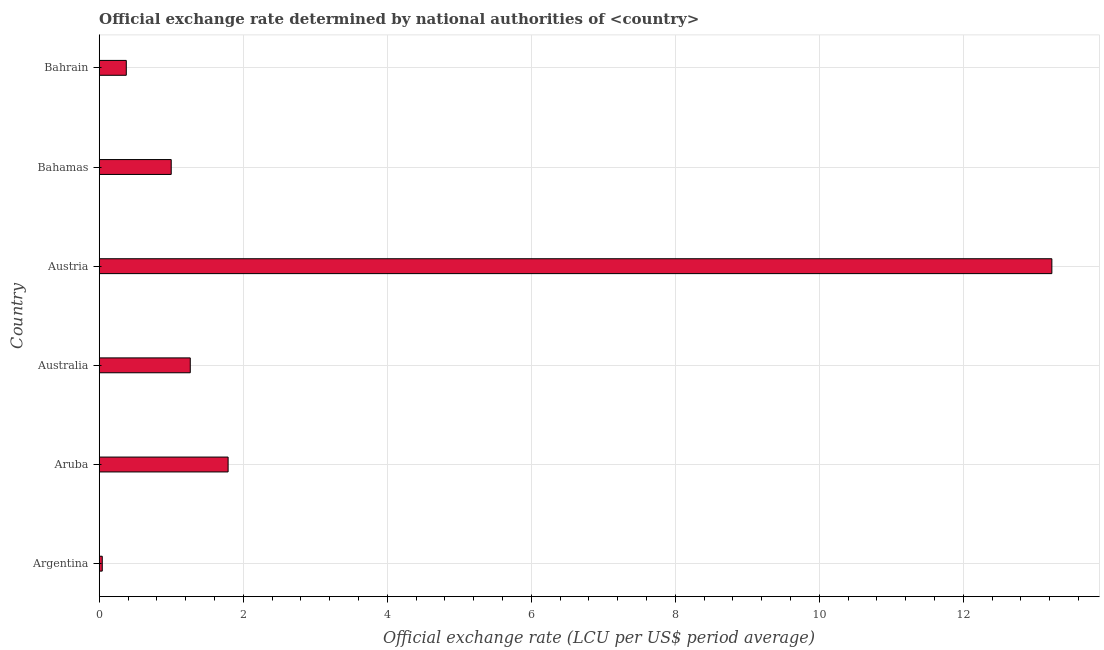What is the title of the graph?
Give a very brief answer. Official exchange rate determined by national authorities of <country>. What is the label or title of the X-axis?
Provide a succinct answer. Official exchange rate (LCU per US$ period average). What is the label or title of the Y-axis?
Make the answer very short. Country. What is the official exchange rate in Aruba?
Give a very brief answer. 1.79. Across all countries, what is the maximum official exchange rate?
Your response must be concise. 13.23. Across all countries, what is the minimum official exchange rate?
Ensure brevity in your answer.  0.04. What is the sum of the official exchange rate?
Your answer should be compact. 17.7. What is the difference between the official exchange rate in Bahamas and Bahrain?
Your response must be concise. 0.62. What is the average official exchange rate per country?
Your answer should be compact. 2.95. What is the median official exchange rate?
Your answer should be compact. 1.13. What is the ratio of the official exchange rate in Argentina to that in Bahamas?
Provide a succinct answer. 0.04. What is the difference between the highest and the second highest official exchange rate?
Provide a succinct answer. 11.44. Is the sum of the official exchange rate in Argentina and Aruba greater than the maximum official exchange rate across all countries?
Your response must be concise. No. What is the difference between the highest and the lowest official exchange rate?
Ensure brevity in your answer.  13.19. In how many countries, is the official exchange rate greater than the average official exchange rate taken over all countries?
Provide a succinct answer. 1. How many bars are there?
Your answer should be very brief. 6. Are all the bars in the graph horizontal?
Provide a short and direct response. Yes. How many countries are there in the graph?
Make the answer very short. 6. Are the values on the major ticks of X-axis written in scientific E-notation?
Make the answer very short. No. What is the Official exchange rate (LCU per US$ period average) of Argentina?
Your answer should be very brief. 0.04. What is the Official exchange rate (LCU per US$ period average) of Aruba?
Ensure brevity in your answer.  1.79. What is the Official exchange rate (LCU per US$ period average) of Australia?
Keep it short and to the point. 1.26. What is the Official exchange rate (LCU per US$ period average) in Austria?
Your answer should be compact. 13.23. What is the Official exchange rate (LCU per US$ period average) in Bahrain?
Make the answer very short. 0.38. What is the difference between the Official exchange rate (LCU per US$ period average) in Argentina and Aruba?
Make the answer very short. -1.75. What is the difference between the Official exchange rate (LCU per US$ period average) in Argentina and Australia?
Your answer should be compact. -1.22. What is the difference between the Official exchange rate (LCU per US$ period average) in Argentina and Austria?
Give a very brief answer. -13.19. What is the difference between the Official exchange rate (LCU per US$ period average) in Argentina and Bahamas?
Offer a very short reply. -0.96. What is the difference between the Official exchange rate (LCU per US$ period average) in Argentina and Bahrain?
Your answer should be very brief. -0.33. What is the difference between the Official exchange rate (LCU per US$ period average) in Aruba and Australia?
Provide a succinct answer. 0.53. What is the difference between the Official exchange rate (LCU per US$ period average) in Aruba and Austria?
Your answer should be compact. -11.44. What is the difference between the Official exchange rate (LCU per US$ period average) in Aruba and Bahamas?
Ensure brevity in your answer.  0.79. What is the difference between the Official exchange rate (LCU per US$ period average) in Aruba and Bahrain?
Ensure brevity in your answer.  1.41. What is the difference between the Official exchange rate (LCU per US$ period average) in Australia and Austria?
Your answer should be very brief. -11.97. What is the difference between the Official exchange rate (LCU per US$ period average) in Australia and Bahamas?
Your response must be concise. 0.26. What is the difference between the Official exchange rate (LCU per US$ period average) in Australia and Bahrain?
Offer a terse response. 0.89. What is the difference between the Official exchange rate (LCU per US$ period average) in Austria and Bahamas?
Offer a terse response. 12.23. What is the difference between the Official exchange rate (LCU per US$ period average) in Austria and Bahrain?
Offer a very short reply. 12.85. What is the difference between the Official exchange rate (LCU per US$ period average) in Bahamas and Bahrain?
Offer a very short reply. 0.62. What is the ratio of the Official exchange rate (LCU per US$ period average) in Argentina to that in Aruba?
Offer a very short reply. 0.02. What is the ratio of the Official exchange rate (LCU per US$ period average) in Argentina to that in Australia?
Provide a short and direct response. 0.03. What is the ratio of the Official exchange rate (LCU per US$ period average) in Argentina to that in Austria?
Offer a very short reply. 0. What is the ratio of the Official exchange rate (LCU per US$ period average) in Argentina to that in Bahamas?
Provide a short and direct response. 0.04. What is the ratio of the Official exchange rate (LCU per US$ period average) in Argentina to that in Bahrain?
Make the answer very short. 0.11. What is the ratio of the Official exchange rate (LCU per US$ period average) in Aruba to that in Australia?
Ensure brevity in your answer.  1.42. What is the ratio of the Official exchange rate (LCU per US$ period average) in Aruba to that in Austria?
Provide a short and direct response. 0.14. What is the ratio of the Official exchange rate (LCU per US$ period average) in Aruba to that in Bahamas?
Give a very brief answer. 1.79. What is the ratio of the Official exchange rate (LCU per US$ period average) in Aruba to that in Bahrain?
Your answer should be compact. 4.76. What is the ratio of the Official exchange rate (LCU per US$ period average) in Australia to that in Austria?
Your answer should be compact. 0.1. What is the ratio of the Official exchange rate (LCU per US$ period average) in Australia to that in Bahamas?
Keep it short and to the point. 1.26. What is the ratio of the Official exchange rate (LCU per US$ period average) in Australia to that in Bahrain?
Make the answer very short. 3.36. What is the ratio of the Official exchange rate (LCU per US$ period average) in Austria to that in Bahamas?
Your answer should be very brief. 13.23. What is the ratio of the Official exchange rate (LCU per US$ period average) in Austria to that in Bahrain?
Your response must be concise. 35.19. What is the ratio of the Official exchange rate (LCU per US$ period average) in Bahamas to that in Bahrain?
Offer a terse response. 2.66. 